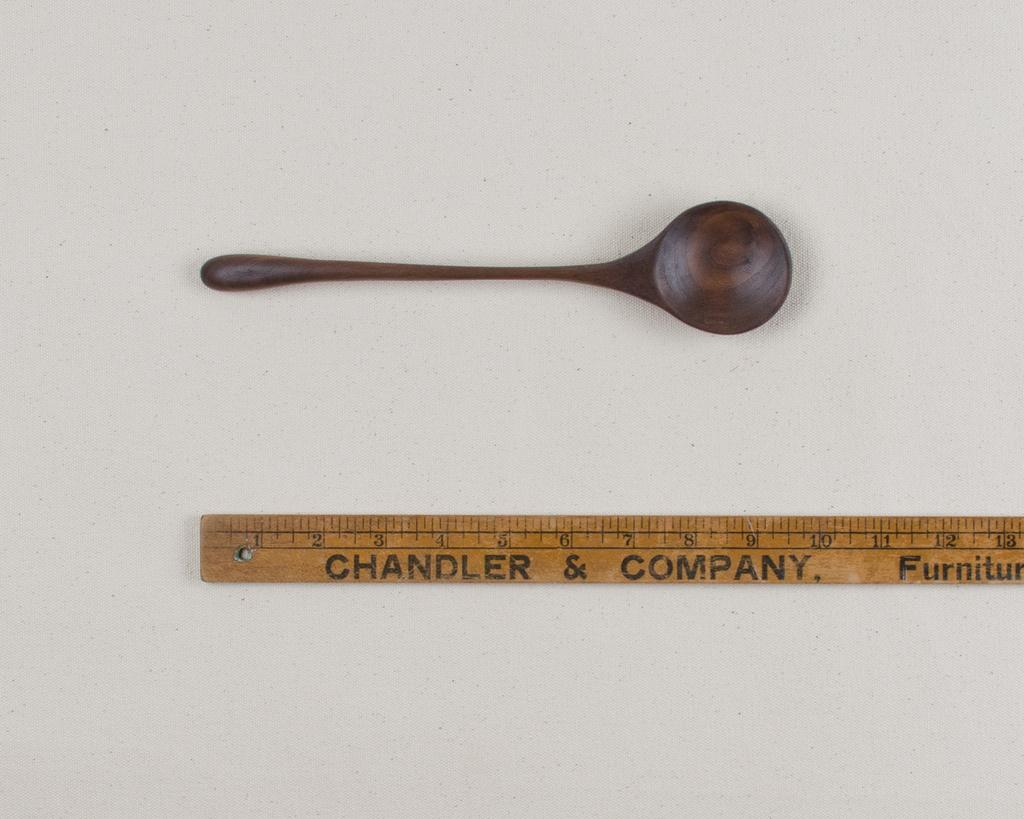Provide a one-sentence caption for the provided image. A wooden spoon next to a Chandler and company ruler. 